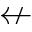Convert formula to latex. <formula><loc_0><loc_0><loc_500><loc_500>\ n l e f t a r r o w</formula> 